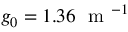Convert formula to latex. <formula><loc_0><loc_0><loc_500><loc_500>g _ { 0 } = 1 . 3 6 m ^ { - 1 }</formula> 